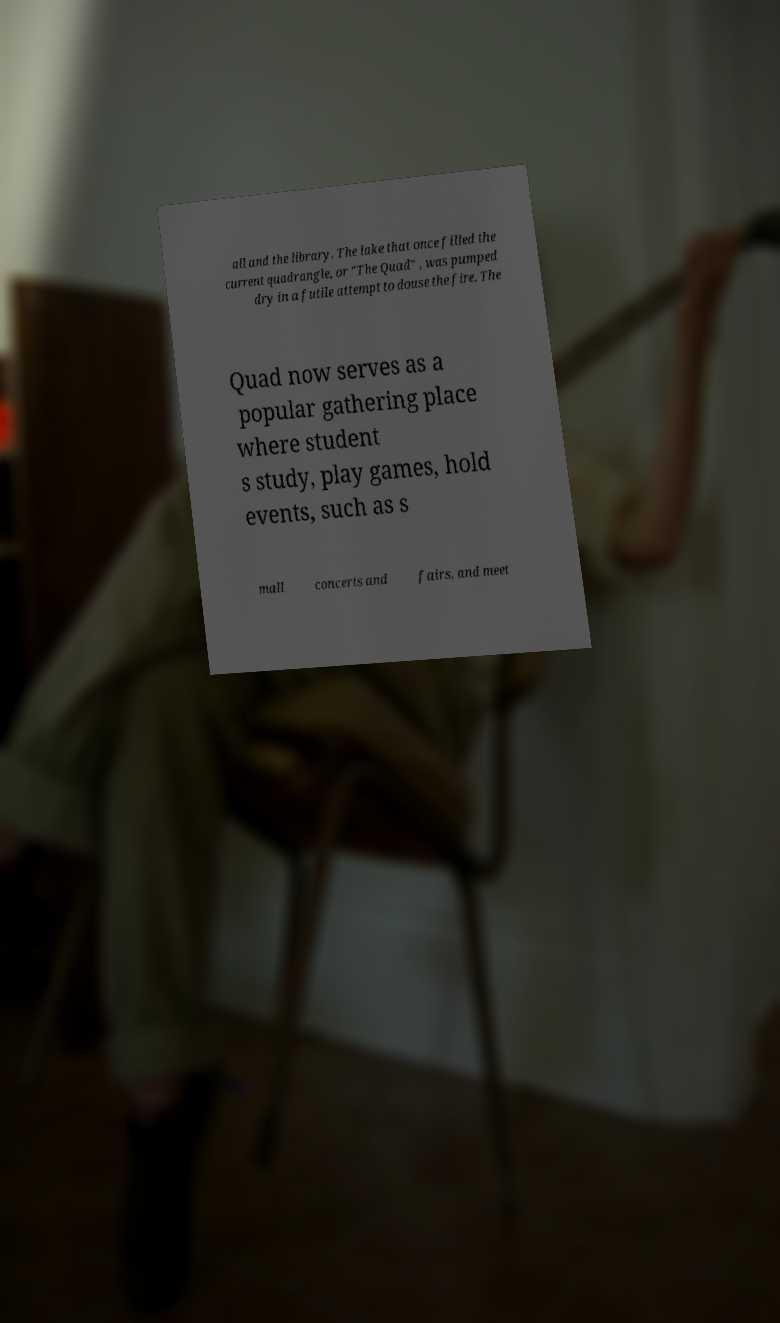Please read and relay the text visible in this image. What does it say? all and the library. The lake that once filled the current quadrangle, or "The Quad" , was pumped dry in a futile attempt to douse the fire. The Quad now serves as a popular gathering place where student s study, play games, hold events, such as s mall concerts and fairs, and meet 